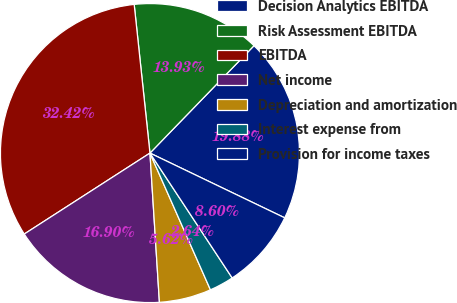<chart> <loc_0><loc_0><loc_500><loc_500><pie_chart><fcel>Decision Analytics EBITDA<fcel>Risk Assessment EBITDA<fcel>EBITDA<fcel>Net income<fcel>Depreciation and amortization<fcel>Interest expense from<fcel>Provision for income taxes<nl><fcel>19.88%<fcel>13.93%<fcel>32.42%<fcel>16.9%<fcel>5.62%<fcel>2.64%<fcel>8.6%<nl></chart> 